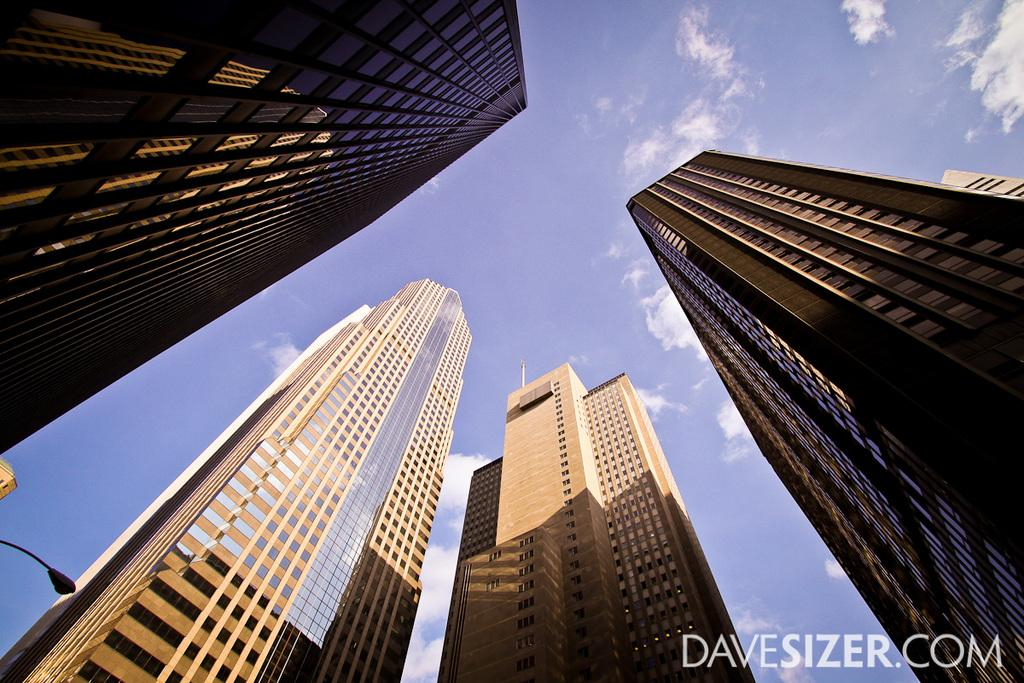How many tall buildings can be seen in the image? There are four tall buildings in the image. What is located on the left side of the image? There is a light pole on the left side of the image. What can be seen in the background of the image? There is a sky visible in the image. What is present in the sky? Clouds are present in the sky. Where is the ornament located in the image? There is no ornament present in the image. Can you see any quicksand in the image? There is no quicksand present in the image. 